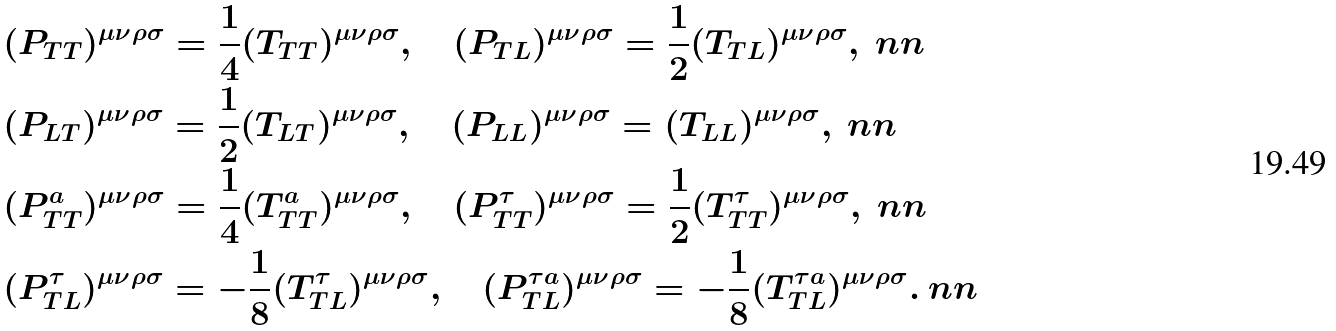Convert formula to latex. <formula><loc_0><loc_0><loc_500><loc_500>& ( P _ { T T } ) ^ { \mu \nu \rho \sigma } = \frac { 1 } { 4 } ( T _ { T T } ) ^ { \mu \nu \rho \sigma } , \quad ( P _ { T L } ) ^ { \mu \nu \rho \sigma } = \frac { 1 } { 2 } ( T _ { T L } ) ^ { \mu \nu \rho \sigma } , \ n n \\ & ( P _ { L T } ) ^ { \mu \nu \rho \sigma } = \frac { 1 } { 2 } ( T _ { L T } ) ^ { \mu \nu \rho \sigma } , \quad ( P _ { L L } ) ^ { \mu \nu \rho \sigma } = ( T _ { L L } ) ^ { \mu \nu \rho \sigma } , \ n n \\ & ( P _ { T T } ^ { a } ) ^ { \mu \nu \rho \sigma } = \frac { 1 } { 4 } ( T _ { T T } ^ { a } ) ^ { \mu \nu \rho \sigma } , \quad ( P _ { T T } ^ { \tau } ) ^ { \mu \nu \rho \sigma } = \frac { 1 } { 2 } ( T _ { T T } ^ { \tau } ) ^ { \mu \nu \rho \sigma } , \ n n \\ & ( P _ { T L } ^ { \tau } ) ^ { \mu \nu \rho \sigma } = - \frac { 1 } { 8 } ( T _ { T L } ^ { \tau } ) ^ { \mu \nu \rho \sigma } , \quad ( P _ { T L } ^ { \tau a } ) ^ { \mu \nu \rho \sigma } = - \frac { 1 } { 8 } ( T _ { T L } ^ { \tau a } ) ^ { \mu \nu \rho \sigma } . \ n n</formula> 